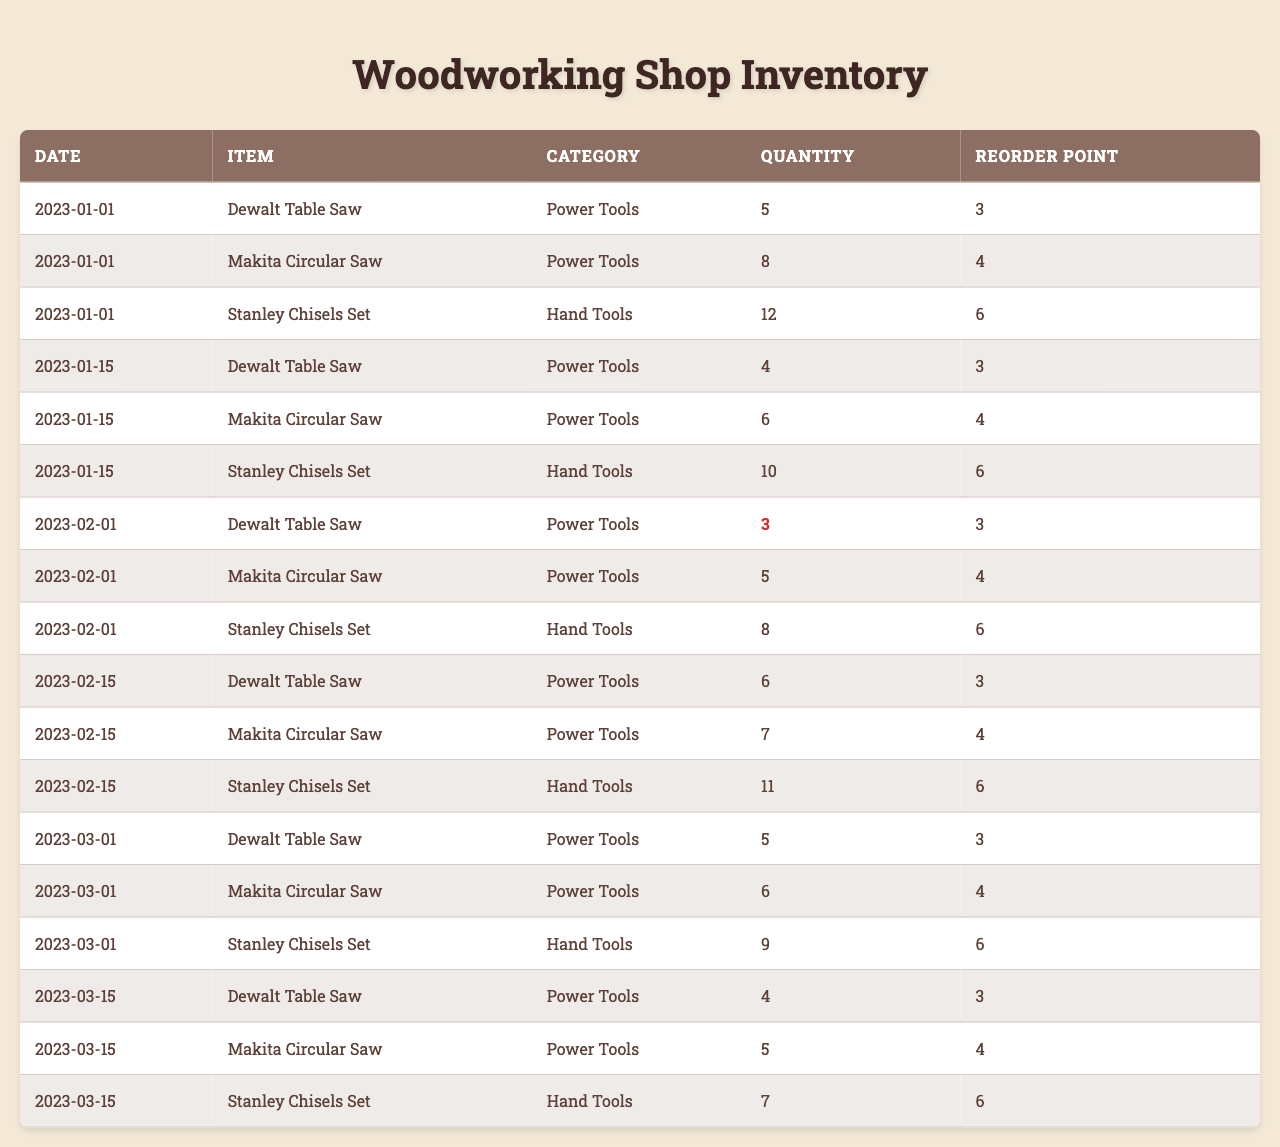What is the quantity of Dewalt Table Saws on 2023-01-01? Looking at the table, on the date 2023-01-01, the quantity of Dewalt Table Saws is explicitly stated as 5.
Answer: 5 Is the quantity of Makita Circular Saws ever below their reorder point? Reviewing the data, the quantity of Makita Circular Saws is 4 on 2023-01-01 (which is below the reorder point of 4), and then again 5 on 2023-02-01 (still below the reorder point of 4). Thus, it is true that the quantity drops below the reorder point.
Answer: Yes What is the total quantity of Stanley Chisels Sets at the end of the quarter? Summing up the quantities of Stanley Chisels Sets from all dates: 12 + 10 + 8 + 11 + 9 + 7 = 57. Thus, the total quantity at the end of the quarter is 57.
Answer: 57 Did the quantity of Dewalt Table Saws increase or decrease from January 1st to January 15th? On January 1st, the quantity was 5 and on January 15th it decreased to 4. Therefore, the quantity decreased.
Answer: Decrease What is the average quantity of Makita Circular Saws throughout the quarter? The quantities are: 8, 6, 5, 7, 6, 5. Adding these gives 37, and dividing by 6 (the number of entries): 37/6 ≈ 6.17. Thus, the average is approximately 6.17.
Answer: 6.17 How many items are below their reorder points at the end of the quarter? Looking through the current quantities at the final date (2023-03-15), Dewalt Table Saw has 4 (above), Makita Circular Saw has 5 (above), and Stanley Chisels Set has 7 (above), meaning none are below their reorder points.
Answer: 0 What is the highest quantity recorded for any tool in the quarter? Scanning through the table, the highest quantity is found for Stanley Chisels Set at 12 on 2023-01-01.
Answer: 12 How many more Makita Circular Saws are present on 2023-02-15 compared to 2023-02-01? The quantity on 2023-02-15 is 7, and on 2023-02-01 it was 5. The difference is 7 - 5 = 2. Thus, there were 2 more on the later date.
Answer: 2 Is there a date when the Stanley Chisels Set had a quantity of exactly 10? Comparing the quantities listed, there is no date in the table that has the Stanley Chisels Set quantity at exactly 10.
Answer: No What is the change in quantity of Dewalt Table Saw from March 1 to March 15? The quantity on March 1 was 5 and on March 15 it was 4. The change is 4 - 5 = -1, indicating a decrease of 1.
Answer: Decrease of 1 